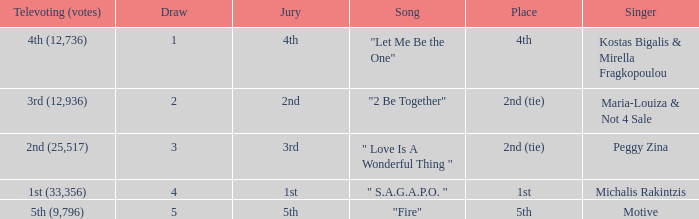What is the greatest draw that has 4th for place? 1.0. 